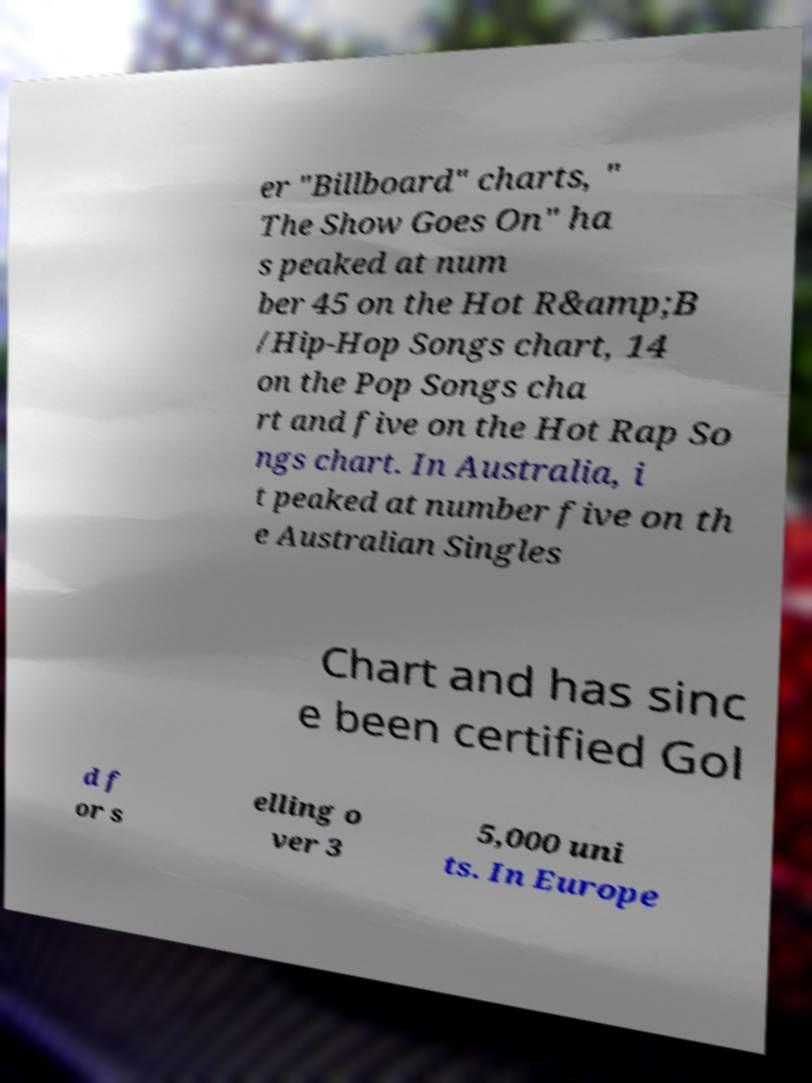Could you extract and type out the text from this image? er "Billboard" charts, " The Show Goes On" ha s peaked at num ber 45 on the Hot R&amp;B /Hip-Hop Songs chart, 14 on the Pop Songs cha rt and five on the Hot Rap So ngs chart. In Australia, i t peaked at number five on th e Australian Singles Chart and has sinc e been certified Gol d f or s elling o ver 3 5,000 uni ts. In Europe 